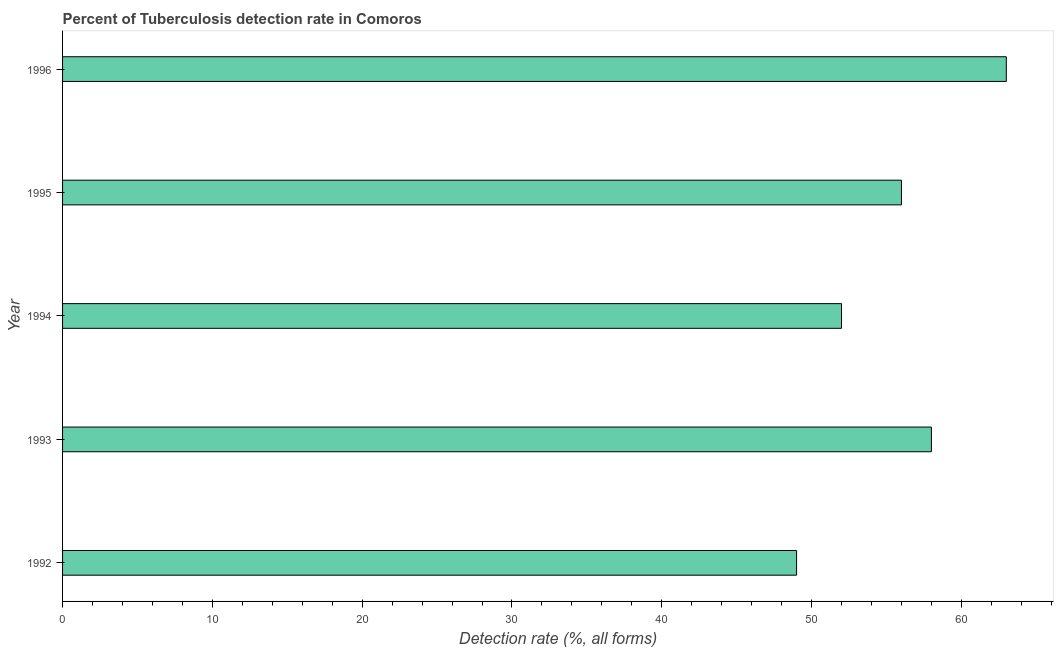Does the graph contain grids?
Offer a very short reply. No. What is the title of the graph?
Offer a terse response. Percent of Tuberculosis detection rate in Comoros. What is the label or title of the X-axis?
Give a very brief answer. Detection rate (%, all forms). What is the label or title of the Y-axis?
Give a very brief answer. Year. Across all years, what is the maximum detection rate of tuberculosis?
Provide a short and direct response. 63. In which year was the detection rate of tuberculosis maximum?
Your response must be concise. 1996. What is the sum of the detection rate of tuberculosis?
Provide a short and direct response. 278. What is the difference between the detection rate of tuberculosis in 1994 and 1995?
Provide a succinct answer. -4. Do a majority of the years between 1993 and 1992 (inclusive) have detection rate of tuberculosis greater than 58 %?
Provide a short and direct response. No. What is the ratio of the detection rate of tuberculosis in 1993 to that in 1995?
Keep it short and to the point. 1.04. Is the difference between the detection rate of tuberculosis in 1993 and 1996 greater than the difference between any two years?
Keep it short and to the point. No. What is the difference between the highest and the second highest detection rate of tuberculosis?
Keep it short and to the point. 5. What is the difference between the highest and the lowest detection rate of tuberculosis?
Your response must be concise. 14. Are the values on the major ticks of X-axis written in scientific E-notation?
Your answer should be compact. No. What is the Detection rate (%, all forms) of 1993?
Offer a terse response. 58. What is the Detection rate (%, all forms) in 1995?
Make the answer very short. 56. What is the Detection rate (%, all forms) in 1996?
Provide a succinct answer. 63. What is the difference between the Detection rate (%, all forms) in 1994 and 1996?
Provide a short and direct response. -11. What is the difference between the Detection rate (%, all forms) in 1995 and 1996?
Keep it short and to the point. -7. What is the ratio of the Detection rate (%, all forms) in 1992 to that in 1993?
Make the answer very short. 0.84. What is the ratio of the Detection rate (%, all forms) in 1992 to that in 1994?
Provide a succinct answer. 0.94. What is the ratio of the Detection rate (%, all forms) in 1992 to that in 1996?
Keep it short and to the point. 0.78. What is the ratio of the Detection rate (%, all forms) in 1993 to that in 1994?
Ensure brevity in your answer.  1.11. What is the ratio of the Detection rate (%, all forms) in 1993 to that in 1995?
Your answer should be very brief. 1.04. What is the ratio of the Detection rate (%, all forms) in 1993 to that in 1996?
Your answer should be compact. 0.92. What is the ratio of the Detection rate (%, all forms) in 1994 to that in 1995?
Provide a succinct answer. 0.93. What is the ratio of the Detection rate (%, all forms) in 1994 to that in 1996?
Keep it short and to the point. 0.82. What is the ratio of the Detection rate (%, all forms) in 1995 to that in 1996?
Your answer should be compact. 0.89. 